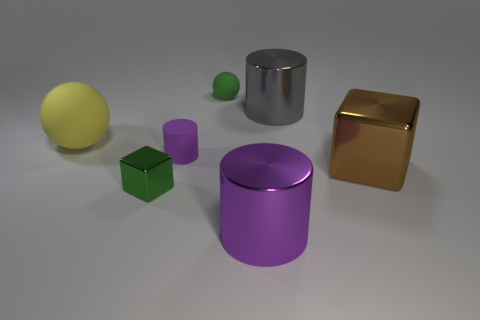Add 1 tiny objects. How many objects exist? 8 Subtract all cylinders. How many objects are left? 4 Add 2 large brown metallic things. How many large brown metallic things are left? 3 Add 5 purple matte things. How many purple matte things exist? 6 Subtract 0 yellow cylinders. How many objects are left? 7 Subtract all large matte things. Subtract all large balls. How many objects are left? 5 